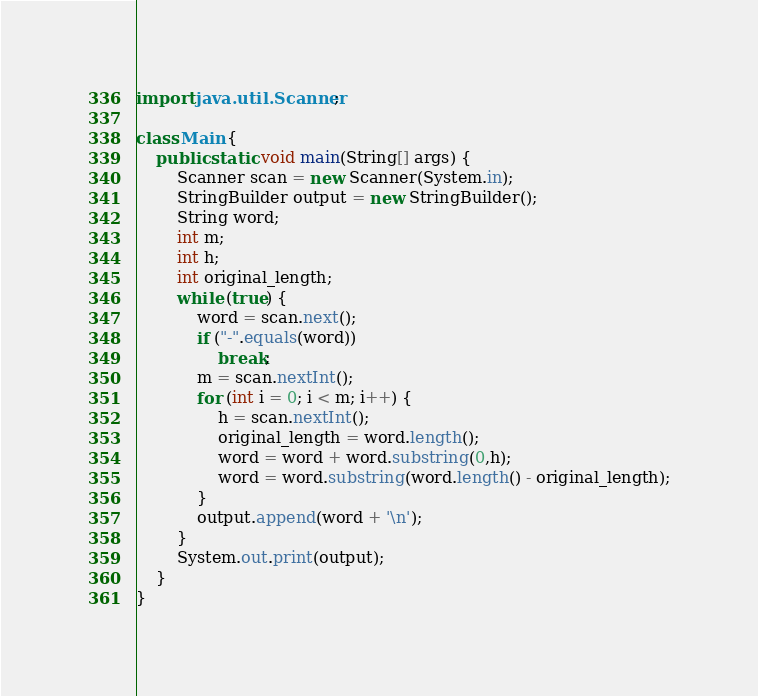<code> <loc_0><loc_0><loc_500><loc_500><_Java_>import java.util.Scanner;
 
class Main {
    public static void main(String[] args) {
        Scanner scan = new Scanner(System.in);
        StringBuilder output = new StringBuilder();
        String word;
        int m;
        int h;
        int original_length;
        while (true) {
            word = scan.next();
            if ("-".equals(word))
                break;
            m = scan.nextInt();
            for (int i = 0; i < m; i++) {
                h = scan.nextInt();
                original_length = word.length();
                word = word + word.substring(0,h);
                word = word.substring(word.length() - original_length);
            }
            output.append(word + '\n');
        }
        System.out.print(output);
    }
}</code> 